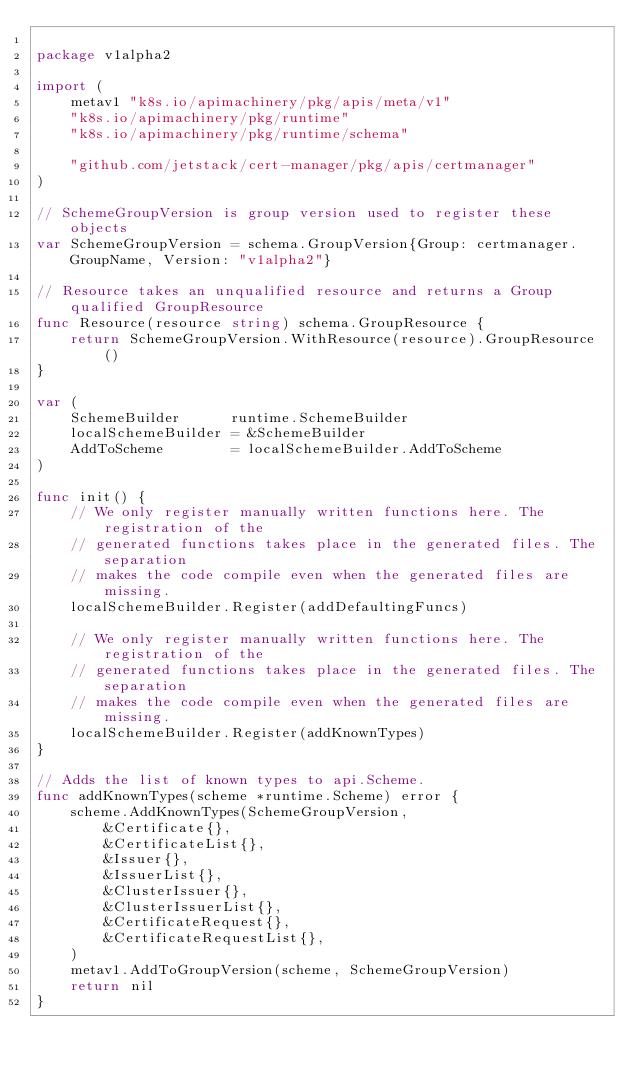<code> <loc_0><loc_0><loc_500><loc_500><_Go_>
package v1alpha2

import (
	metav1 "k8s.io/apimachinery/pkg/apis/meta/v1"
	"k8s.io/apimachinery/pkg/runtime"
	"k8s.io/apimachinery/pkg/runtime/schema"

	"github.com/jetstack/cert-manager/pkg/apis/certmanager"
)

// SchemeGroupVersion is group version used to register these objects
var SchemeGroupVersion = schema.GroupVersion{Group: certmanager.GroupName, Version: "v1alpha2"}

// Resource takes an unqualified resource and returns a Group qualified GroupResource
func Resource(resource string) schema.GroupResource {
	return SchemeGroupVersion.WithResource(resource).GroupResource()
}

var (
	SchemeBuilder      runtime.SchemeBuilder
	localSchemeBuilder = &SchemeBuilder
	AddToScheme        = localSchemeBuilder.AddToScheme
)

func init() {
	// We only register manually written functions here. The registration of the
	// generated functions takes place in the generated files. The separation
	// makes the code compile even when the generated files are missing.
	localSchemeBuilder.Register(addDefaultingFuncs)

	// We only register manually written functions here. The registration of the
	// generated functions takes place in the generated files. The separation
	// makes the code compile even when the generated files are missing.
	localSchemeBuilder.Register(addKnownTypes)
}

// Adds the list of known types to api.Scheme.
func addKnownTypes(scheme *runtime.Scheme) error {
	scheme.AddKnownTypes(SchemeGroupVersion,
		&Certificate{},
		&CertificateList{},
		&Issuer{},
		&IssuerList{},
		&ClusterIssuer{},
		&ClusterIssuerList{},
		&CertificateRequest{},
		&CertificateRequestList{},
	)
	metav1.AddToGroupVersion(scheme, SchemeGroupVersion)
	return nil
}
</code> 